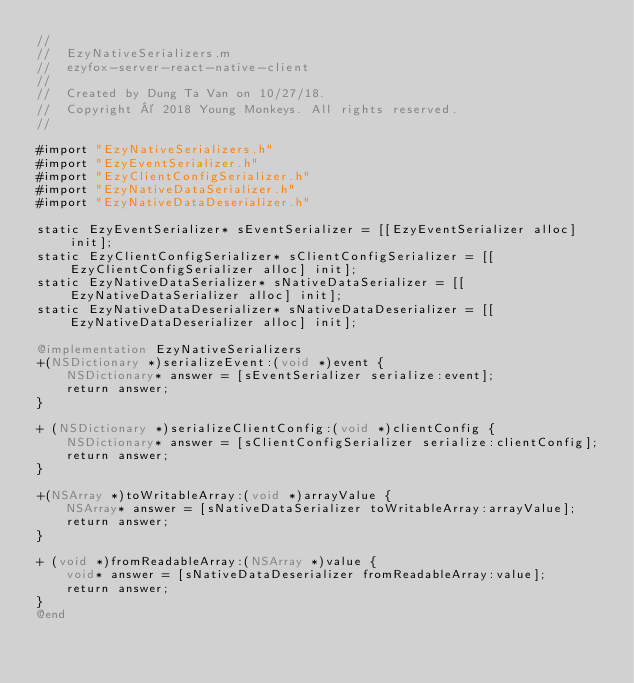<code> <loc_0><loc_0><loc_500><loc_500><_ObjectiveC_>//
//  EzyNativeSerializers.m
//  ezyfox-server-react-native-client
//
//  Created by Dung Ta Van on 10/27/18.
//  Copyright © 2018 Young Monkeys. All rights reserved.
//

#import "EzyNativeSerializers.h"
#import "EzyEventSerializer.h"
#import "EzyClientConfigSerializer.h"
#import "EzyNativeDataSerializer.h"
#import "EzyNativeDataDeserializer.h"

static EzyEventSerializer* sEventSerializer = [[EzyEventSerializer alloc] init];
static EzyClientConfigSerializer* sClientConfigSerializer = [[EzyClientConfigSerializer alloc] init];
static EzyNativeDataSerializer* sNativeDataSerializer = [[EzyNativeDataSerializer alloc] init];
static EzyNativeDataDeserializer* sNativeDataDeserializer = [[EzyNativeDataDeserializer alloc] init];

@implementation EzyNativeSerializers
+(NSDictionary *)serializeEvent:(void *)event {
    NSDictionary* answer = [sEventSerializer serialize:event];
    return answer;
}

+ (NSDictionary *)serializeClientConfig:(void *)clientConfig {
    NSDictionary* answer = [sClientConfigSerializer serialize:clientConfig];
    return answer;
}

+(NSArray *)toWritableArray:(void *)arrayValue {
    NSArray* answer = [sNativeDataSerializer toWritableArray:arrayValue];
    return answer;
}

+ (void *)fromReadableArray:(NSArray *)value {
    void* answer = [sNativeDataDeserializer fromReadableArray:value];
    return answer;
}
@end
</code> 